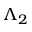<formula> <loc_0><loc_0><loc_500><loc_500>\Lambda _ { 2 }</formula> 